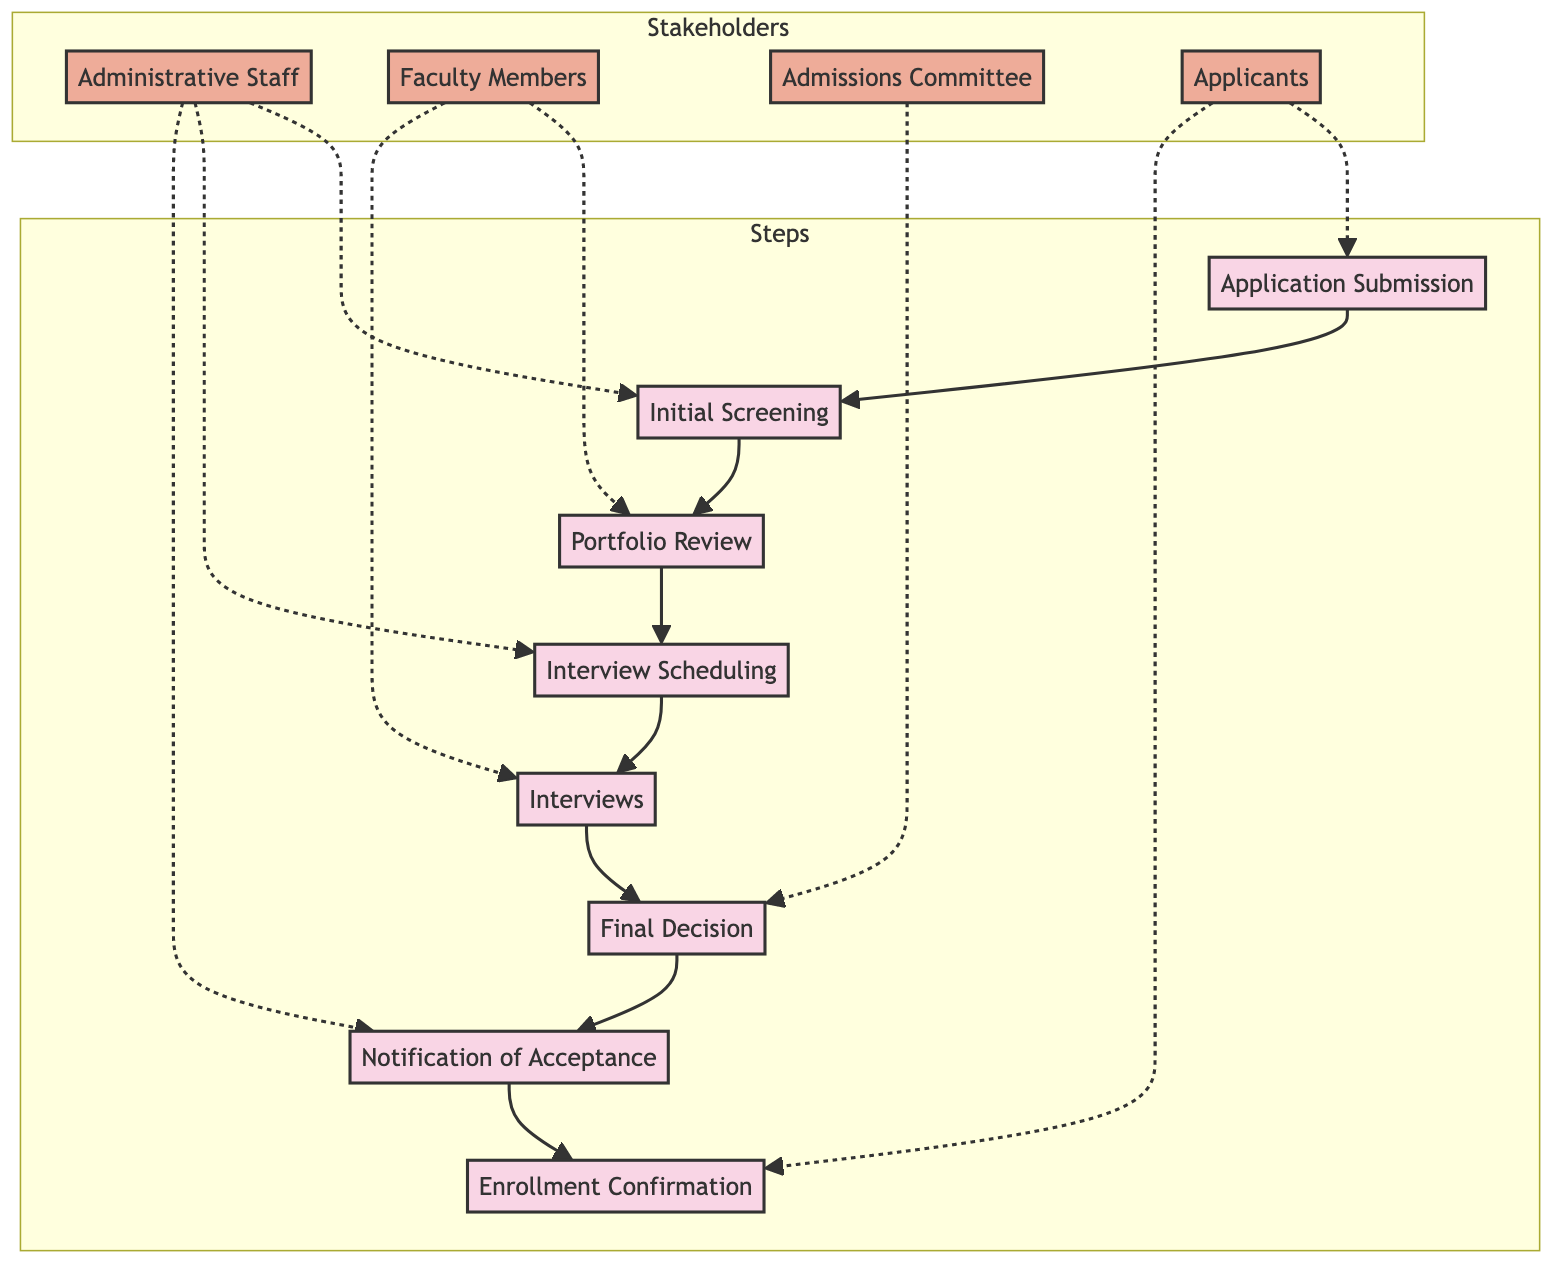What is the first step in the enrollment process? The first step in the enrollment process is labeled "Application Submission" in the diagram, indicating that students start by submitting their applications.
Answer: Application Submission How many steps are there in the enrollment process? Counting the steps labeled in the diagram, there are a total of 8 distinct steps depicted along the flowchart.
Answer: 8 Which stakeholder is involved in the "Final Decision" step? Following the flow of the diagram, the "Final Decision" step connects directly to the "Admissions Committee," indicating that this stakeholder is responsible for making the final admission decisions.
Answer: Admissions Committee What step comes immediately after "Interviews"? By reviewing the flowchart, the step that follows "Interviews" is "Final Decision," which shows the sequence of the admission process.
Answer: Final Decision Who submits applications in the process? Referring to the diagram, the stakeholder labeled "Applicants" is directly connected to the "Application Submission" step, indicating they are the ones who submit applications.
Answer: Applicants Which two stakeholders are involved in the "Portfolio Review" step? The diagram denotes that "Faculty Members" perform the "Portfolio Review," but it does not indicate another stakeholder in this specific step. Thus, the only stakeholder involved here is "Faculty Members."
Answer: Faculty Members What happens after "Notification of Acceptance"? The diagram shows that the action that follows "Notification of Acceptance" is "Enrollment Confirmation," indicating the next step for accepted students.
Answer: Enrollment Confirmation Which step does the "Administrative Staff" engage with during application screening? The "Administrative Staff" are involved in the step labeled "Initial Screening," where they review applications for completeness and eligibility.
Answer: Initial Screening What is the purpose of the "Interview Scheduling" step? By observing the flow of the diagram, the "Interview Scheduling" step aims to arrange interviews for eligible students with the Fine Arts faculty, marking its role in the process.
Answer: Schedule interviews 